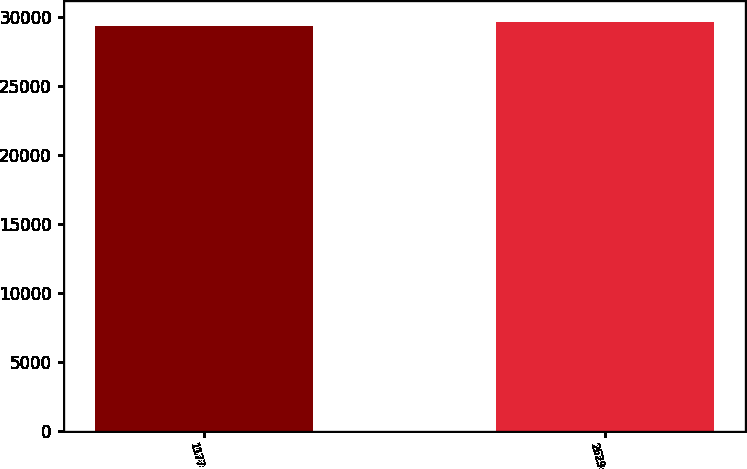Convert chart to OTSL. <chart><loc_0><loc_0><loc_500><loc_500><bar_chart><fcel>1177<fcel>2629<nl><fcel>29343<fcel>29660<nl></chart> 